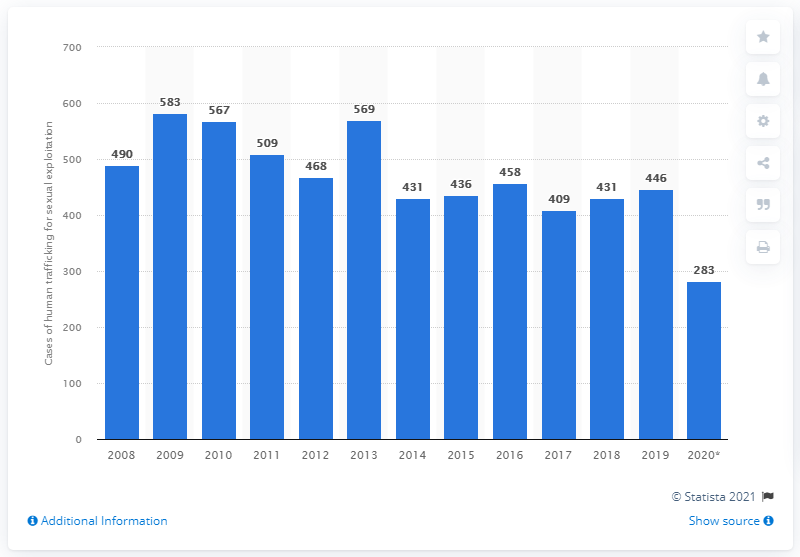What does the asterisk next to the year 2020 on the chart indicate? The asterisk next to the year 2020 on the bar chart typically denotes that there is some additional information or special consideration associated with the data for that year. For instance, it might indicate that the data is provisional and subject to revision, or perhaps it reflects changes in data collection methods or reporting standards. It's essential to check the source or accompanying notes for precise details. 